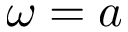<formula> <loc_0><loc_0><loc_500><loc_500>\omega = a</formula> 